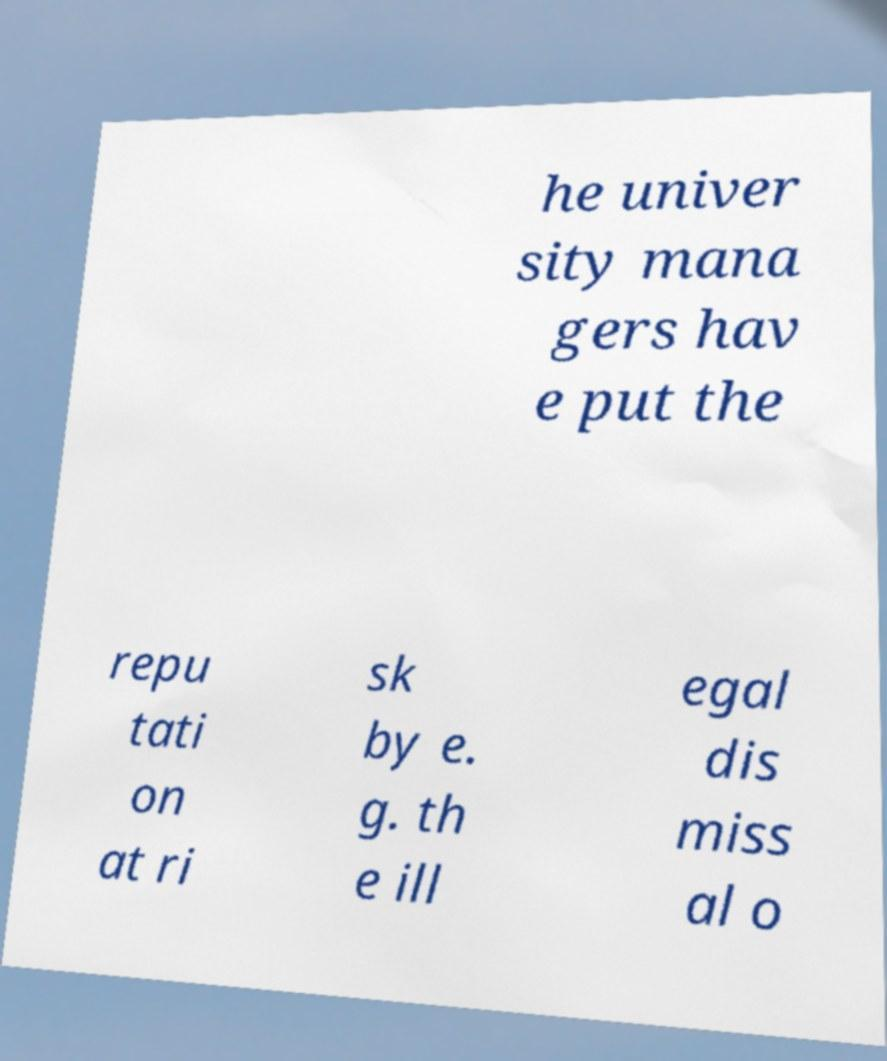For documentation purposes, I need the text within this image transcribed. Could you provide that? he univer sity mana gers hav e put the repu tati on at ri sk by e. g. th e ill egal dis miss al o 